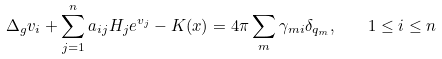Convert formula to latex. <formula><loc_0><loc_0><loc_500><loc_500>\Delta _ { g } v _ { i } + \sum _ { j = 1 } ^ { n } a _ { i j } H _ { j } e ^ { v _ { j } } - K ( x ) = 4 \pi \sum _ { m } \gamma _ { m i } \delta _ { q _ { m } } , \quad 1 \leq i \leq n</formula> 